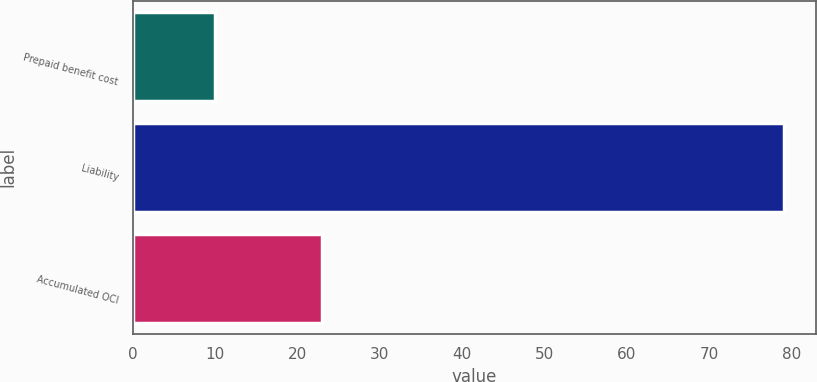Convert chart. <chart><loc_0><loc_0><loc_500><loc_500><bar_chart><fcel>Prepaid benefit cost<fcel>Liability<fcel>Accumulated OCI<nl><fcel>10<fcel>79<fcel>23<nl></chart> 